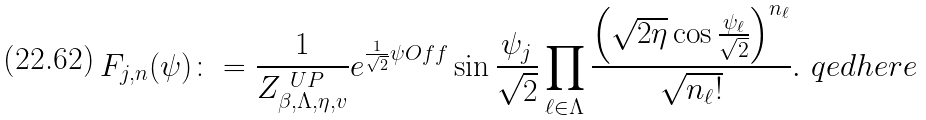<formula> <loc_0><loc_0><loc_500><loc_500>F _ { j , n } ( \psi ) \colon = \frac { 1 } { Z _ { \beta , \Lambda , \eta , v } ^ { \ U P } } e ^ { \frac { 1 } { \sqrt { 2 } } \psi O f { f } } \sin \frac { \psi _ { j } } { \sqrt { 2 } } \prod _ { \ell \in \Lambda } \frac { \left ( \sqrt { 2 \eta } \cos \frac { \psi _ { \ell } } { \sqrt { 2 } } \right ) ^ { n _ { \ell } } } { \sqrt { n _ { \ell } ! } } . \ q e d h e r e</formula> 